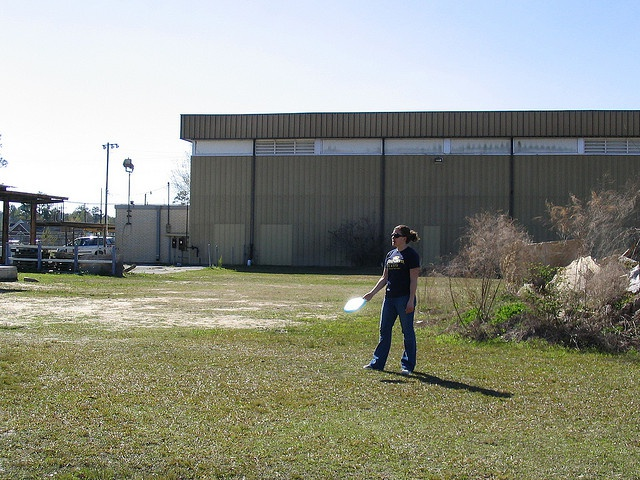Describe the objects in this image and their specific colors. I can see people in lavender, black, gray, and olive tones, car in lavender, gray, black, navy, and darkgray tones, and frisbee in lavender, white, and lightblue tones in this image. 